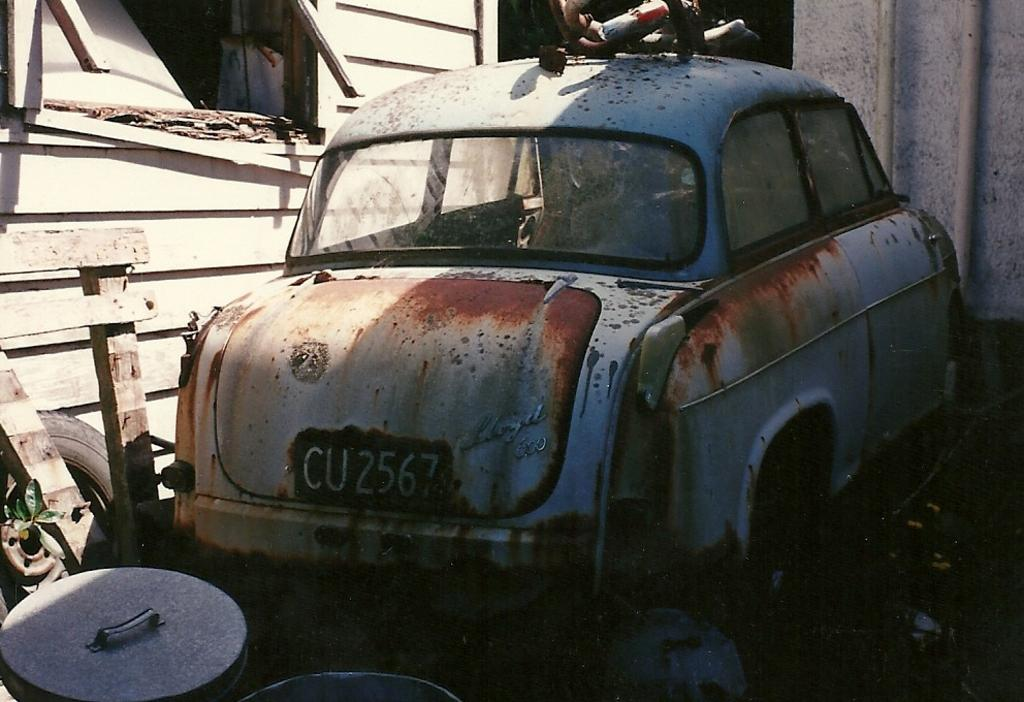What is the condition of the car in the image? The car in the image is spoiled. Where is the car located in relation to other structures? The car is near a shed. What can be seen behind the car? There are things visible behind the car. What type of material is used for the planks beside the car? The wooden planks are beside the car. What type of wall is present in the image? There is a wooden wall in the image. What type of crayon is the secretary using to draw on the expert's report in the image? There is no secretary, expert, or crayon present in the image. 